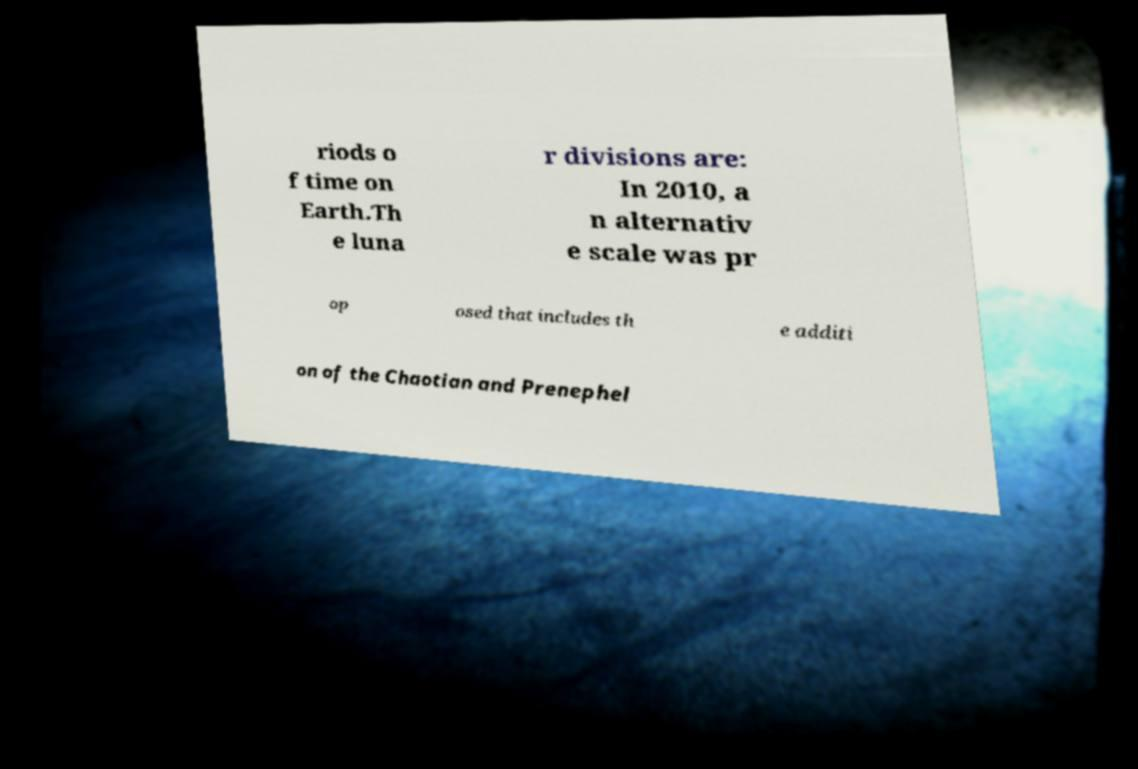I need the written content from this picture converted into text. Can you do that? riods o f time on Earth.Th e luna r divisions are: In 2010, a n alternativ e scale was pr op osed that includes th e additi on of the Chaotian and Prenephel 